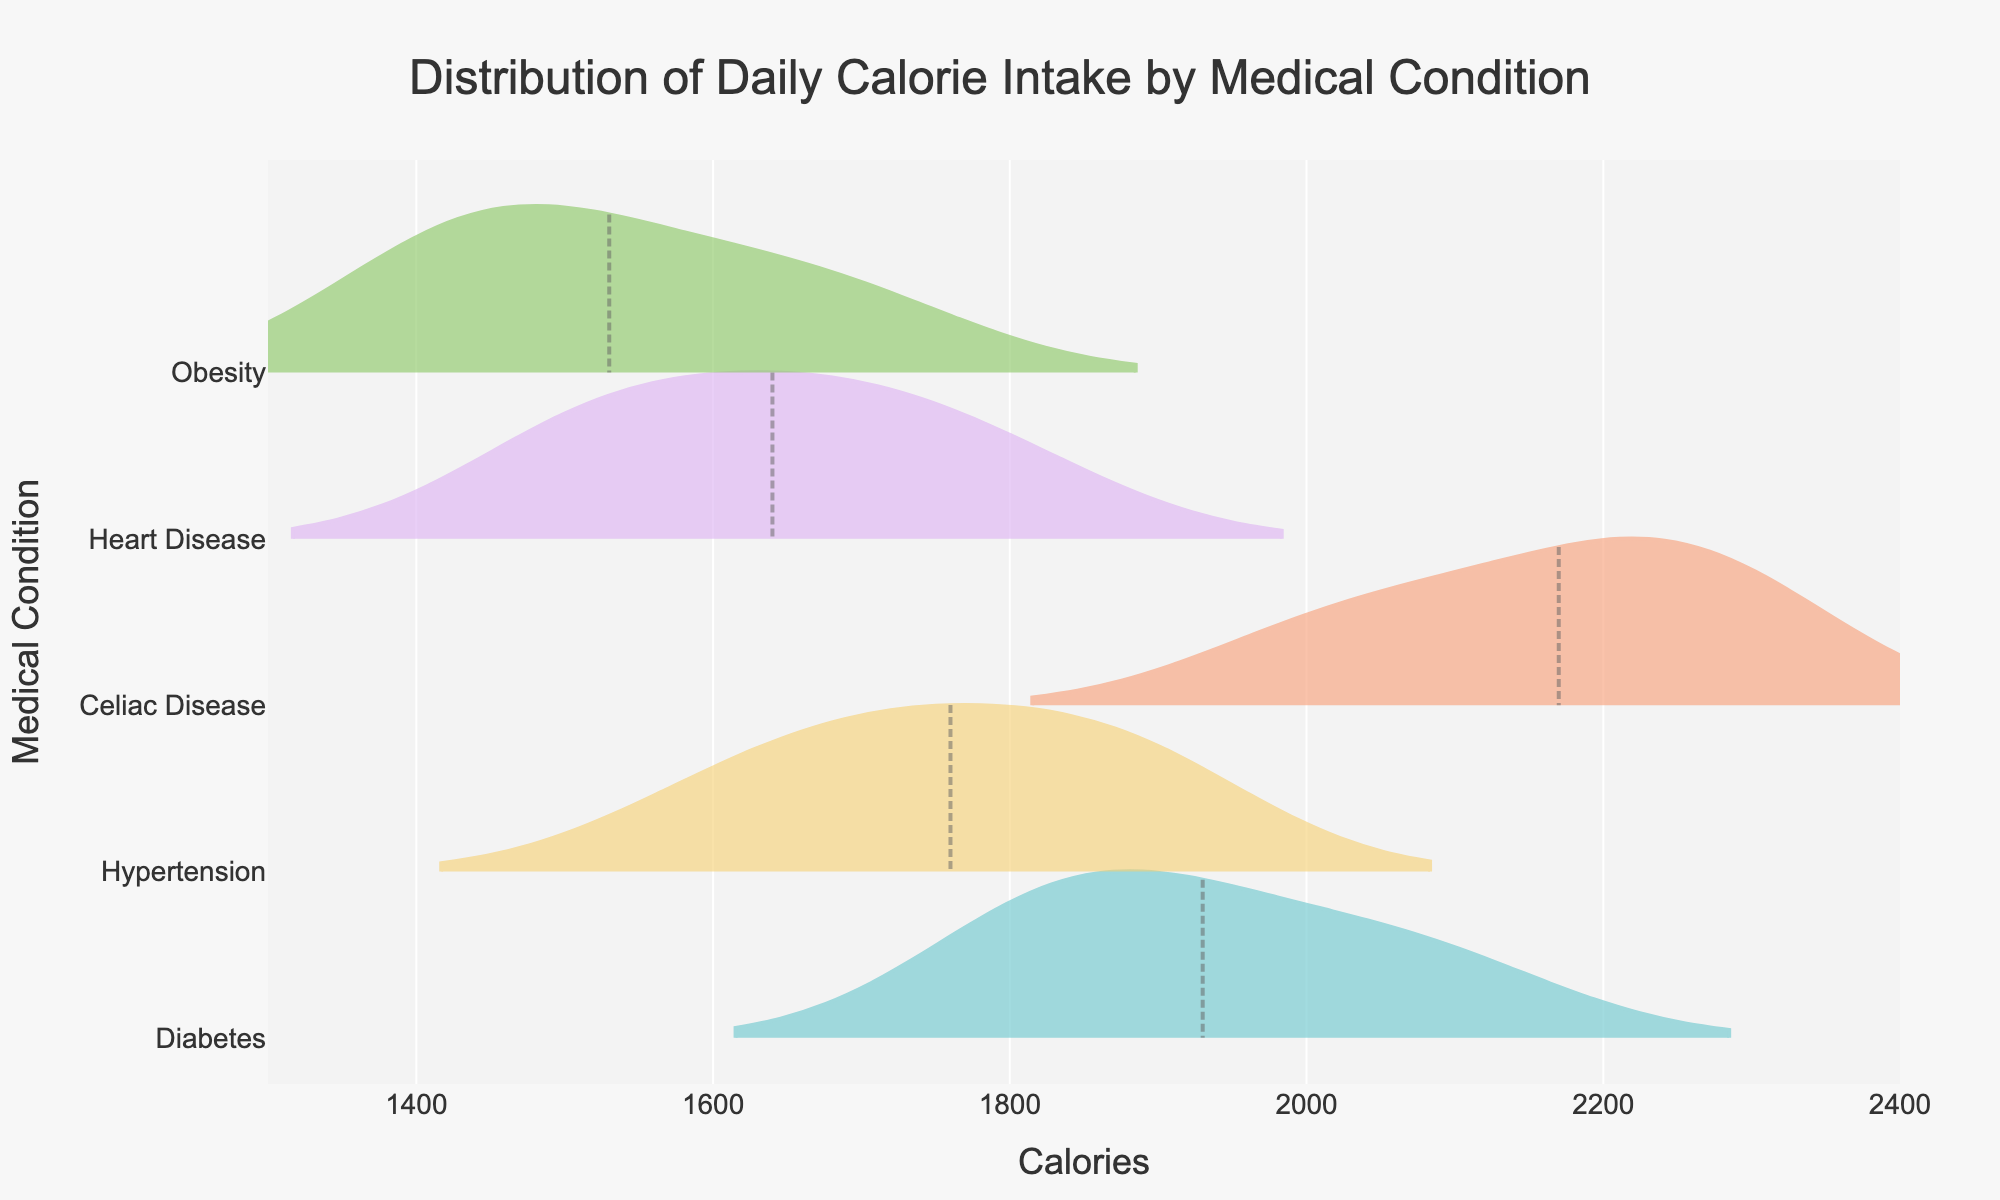What is the title of the plot? The title is usually placed at the top of the plot and clearly displayed. Reading it directly from the plot provides the necessary information.
Answer: Distribution of Daily Calorie Intake by Medical Condition Which condition has the widest distribution of calorie intake? Looking at the horizontal spread of each condition's density plot helps to identify which one spans the widest range of calories.
Answer: Celiac Disease Which condition shows the lowest average calorie intake? The meanline visible for each condition indicates the average. By comparing the meanlines, the lowest one can be identified.
Answer: Obesity What is the average calorie intake for patients with Hypertension? The meanline represents the average calorie intake for each condition. By looking at the position of the meanline for Hypertension, the average can be determined.
Answer: Around 1760 calories Which condition has the highest peak in the density distribution? The peak of the density distribution is the highest point on the plot for each condition, indicating where the most data points lie.
Answer: Diabetes How does the average calorie intake for Heart Disease compare to that of Diabetes? By examining the position of the meanlines for Heart Disease and Diabetes, it can be assessed how they compare to each other.
Answer: Lower for Heart Disease What is the range of calorie intake for patients with Obesity? The density plot's spread from the lowest to the highest calorie count shows the range for each condition.
Answer: 1400 to 1700 calories Which condition has a similar average calorie intake to Diabetes? Compare the meanlines for Diabetes and the other conditions to find the one closest to Diabetes.
Answer: Celiac Disease What is the overall trend in calorie intake among the different conditions? By observing all the density plots, an overall trend can be inferred in terms of calorie intake ranges and averages among the conditions.
Answer: Varies widely, with Heart Disease and Obesity having lower averages and narrower ranges compared to Diabetes and Celiac Disease How do the calorie intakes for Hypertension and Heart Disease patients compare in terms of range and average? Review the distribution range and the meanlines for both conditions to compare their calorie intake in terms of spread and average values.
Answer: Hypertension has a wider spread and higher average than Heart Disease 